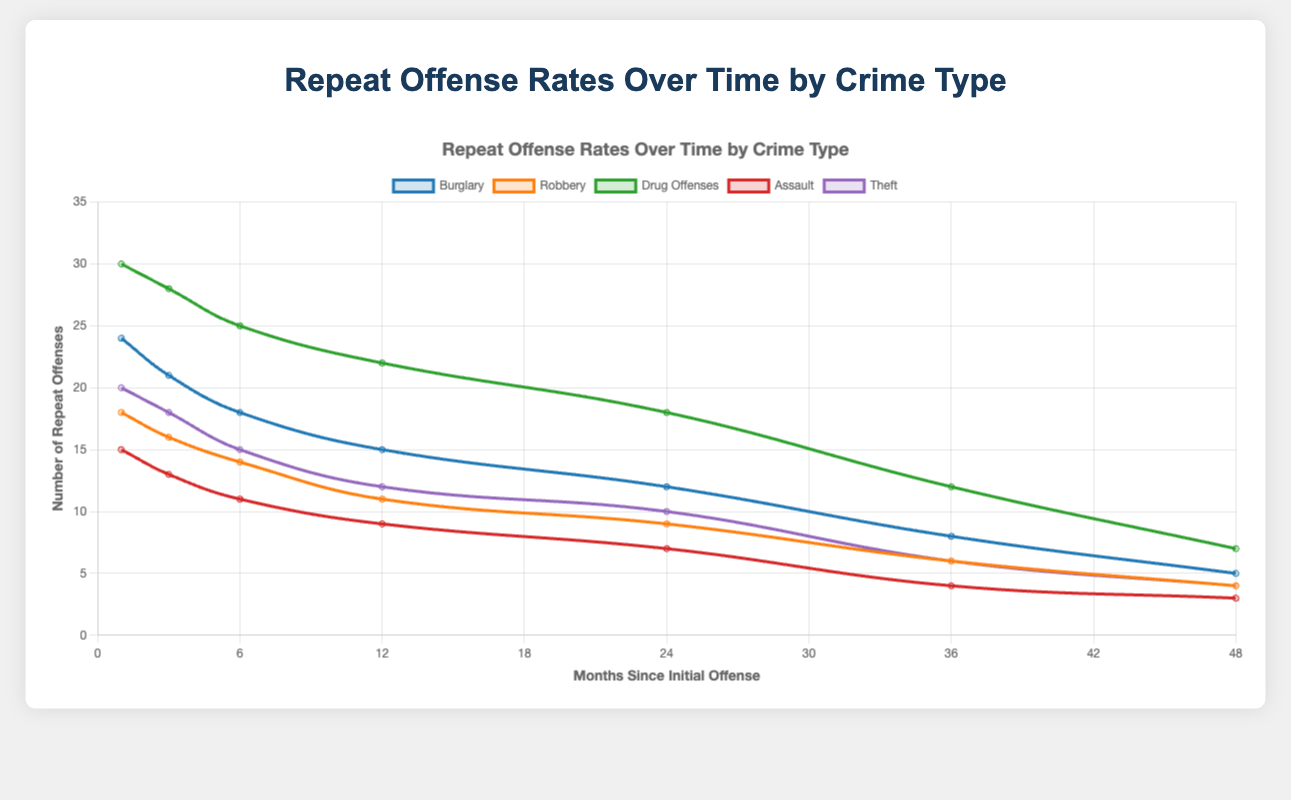What crime type has the highest number of repeat offenses at 1 month since the initial offense? By observing the initial repeat offenses at the 1-month mark for all crime types, we can compare the values: Burglary (24), Robbery (18), Drug Offenses (30), Assault (15), and Theft (20). Drug Offenses show the highest number.
Answer: Drug Offenses Which crime type shows the greatest decrease in repeat offenses from 1 month to 48 months? To find the greatest decrease, calculate the difference between repeat offenses at 1 month and 48 months for each crime type. The decreases are: Burglary (24 - 5 = 19), Robbery (18 - 4 = 14), Drug Offenses (30 - 7 = 23), Assault (15 - 3 = 12), Theft (20 - 4 = 16). Drug Offenses have the greatest decrease.
Answer: Drug Offenses At what time since the initial offense does Burglary drop below 10 repeat offenses? Observing the data for Burglary, the repeat offenses drop below 10 at 36 months with 8 repeat offenses and continue to drop at 48 months with 5 repeat offenses.
Answer: 36 months How does the trend in repeat offenses for Assault compare with that of Robbery over time? Both crime types show a downward trend in repeat offenses over time. However, Assault starts lower at 15 repeat offenses at 1 month, decreasing to 3 at 48 months, whereas Robbery starts at 18 and drops to 4. While both decrease steadily, Assault shows a marginally sharper decline.
Answer: Both decrease steadily, but Assault declines more sharply What is the average number of repeat offenses for Theft from 1 to 12 months? Calculate the average by summing the values at 1, 3, 6, and 12 months (20, 18, 15, 12) and dividing by 4. The sum is 65; dividing by 4 gives an average of 16.25.
Answer: 16.25 Between which months does Drug Offenses see the most significant drop in repeat offenses? By reviewing the values for Drug Offenses, the largest drop can be noted between 1 month (30 repeat offenses) and 48 months (7 repeat offenses). The biggest single drop is between 24 months (18) and 36 months (12), which is a drop of 6.
Answer: Between 24 and 36 months Which crime type consistently has the lowest number of repeat offenses over time? Reviewing the repeat offenses for each type at various months, Assault shows the lowest starting at 15 and decreasing to 3, consistently lower than other crime types across all time points.
Answer: Assault Is there any crime type where the number of repeat offenses decreases uniformly over each subsequent interval? Observing the data, all crime types show a decrease over time, but none decrease uniformly. Each has varying differences in their reductions between intervals.
Answer: No What's the total decrease in repeat offenses for Burglary from 6 to 48 months? Calculate the decrease from 18 at 6 months to 5 at 48 months, which results in a total decrease of 18 - 5 = 13.
Answer: 13 